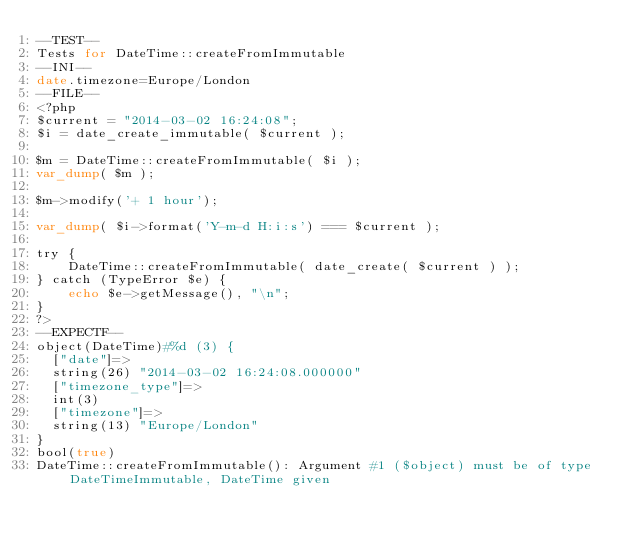<code> <loc_0><loc_0><loc_500><loc_500><_PHP_>--TEST--
Tests for DateTime::createFromImmutable
--INI--
date.timezone=Europe/London
--FILE--
<?php
$current = "2014-03-02 16:24:08";
$i = date_create_immutable( $current );

$m = DateTime::createFromImmutable( $i );
var_dump( $m );

$m->modify('+ 1 hour');

var_dump( $i->format('Y-m-d H:i:s') === $current );

try {
    DateTime::createFromImmutable( date_create( $current ) );
} catch (TypeError $e) {
    echo $e->getMessage(), "\n";
}
?>
--EXPECTF--
object(DateTime)#%d (3) {
  ["date"]=>
  string(26) "2014-03-02 16:24:08.000000"
  ["timezone_type"]=>
  int(3)
  ["timezone"]=>
  string(13) "Europe/London"
}
bool(true)
DateTime::createFromImmutable(): Argument #1 ($object) must be of type DateTimeImmutable, DateTime given
</code> 